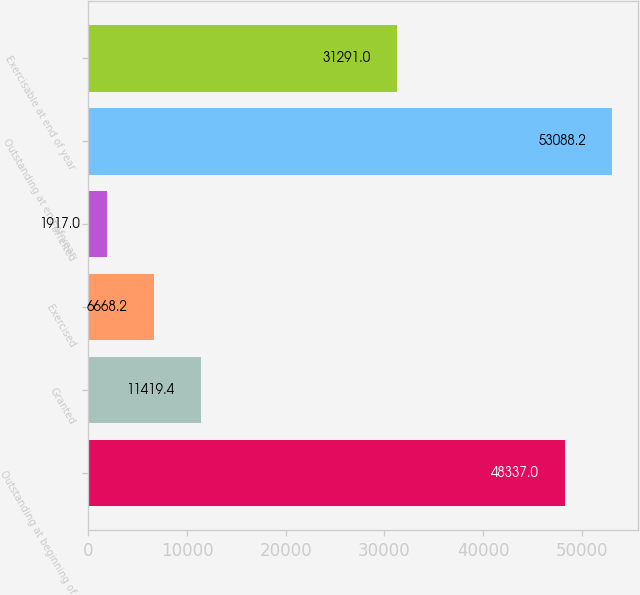Convert chart. <chart><loc_0><loc_0><loc_500><loc_500><bar_chart><fcel>Outstanding at beginning of<fcel>Granted<fcel>Exercised<fcel>Forfeited<fcel>Outstanding at end of year<fcel>Exercisable at end of year<nl><fcel>48337<fcel>11419.4<fcel>6668.2<fcel>1917<fcel>53088.2<fcel>31291<nl></chart> 